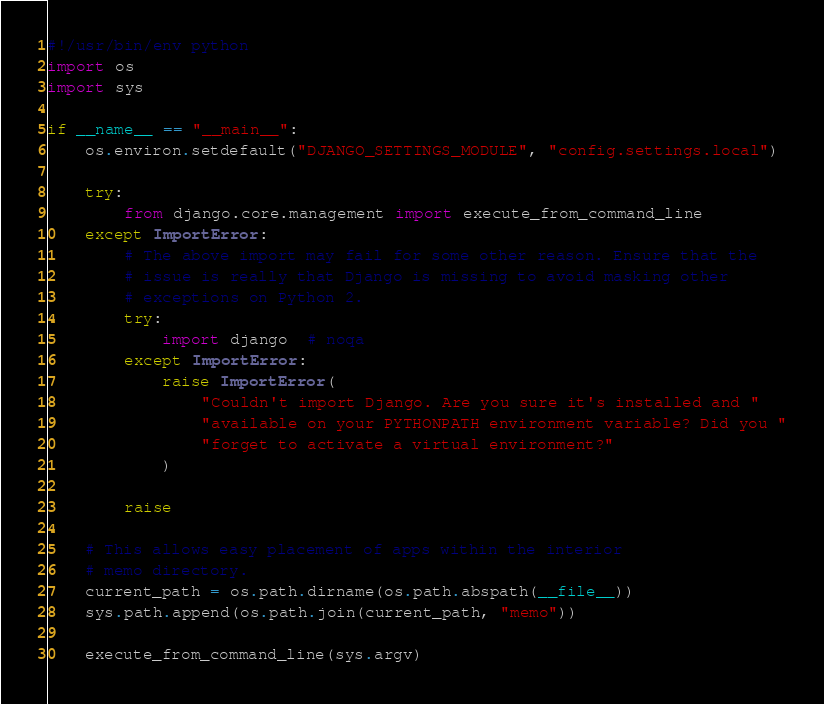<code> <loc_0><loc_0><loc_500><loc_500><_Python_>#!/usr/bin/env python
import os
import sys

if __name__ == "__main__":
    os.environ.setdefault("DJANGO_SETTINGS_MODULE", "config.settings.local")

    try:
        from django.core.management import execute_from_command_line
    except ImportError:
        # The above import may fail for some other reason. Ensure that the
        # issue is really that Django is missing to avoid masking other
        # exceptions on Python 2.
        try:
            import django  # noqa
        except ImportError:
            raise ImportError(
                "Couldn't import Django. Are you sure it's installed and "
                "available on your PYTHONPATH environment variable? Did you "
                "forget to activate a virtual environment?"
            )

        raise

    # This allows easy placement of apps within the interior
    # memo directory.
    current_path = os.path.dirname(os.path.abspath(__file__))
    sys.path.append(os.path.join(current_path, "memo"))

    execute_from_command_line(sys.argv)
</code> 